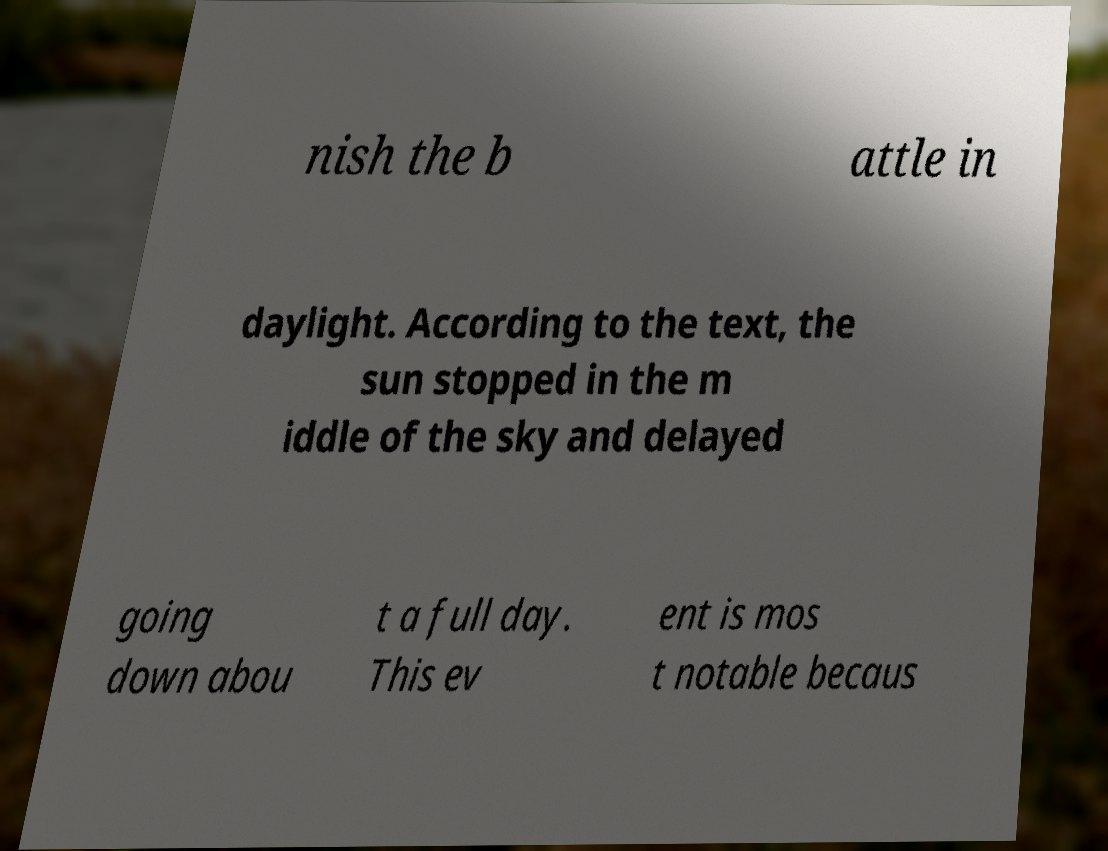Could you assist in decoding the text presented in this image and type it out clearly? nish the b attle in daylight. According to the text, the sun stopped in the m iddle of the sky and delayed going down abou t a full day. This ev ent is mos t notable becaus 